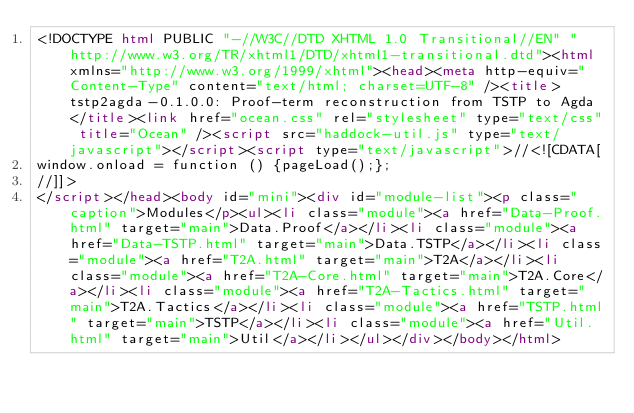<code> <loc_0><loc_0><loc_500><loc_500><_HTML_><!DOCTYPE html PUBLIC "-//W3C//DTD XHTML 1.0 Transitional//EN" "http://www.w3.org/TR/xhtml1/DTD/xhtml1-transitional.dtd"><html xmlns="http://www.w3.org/1999/xhtml"><head><meta http-equiv="Content-Type" content="text/html; charset=UTF-8" /><title>tstp2agda-0.1.0.0: Proof-term reconstruction from TSTP to Agda</title><link href="ocean.css" rel="stylesheet" type="text/css" title="Ocean" /><script src="haddock-util.js" type="text/javascript"></script><script type="text/javascript">//<![CDATA[
window.onload = function () {pageLoad();};
//]]>
</script></head><body id="mini"><div id="module-list"><p class="caption">Modules</p><ul><li class="module"><a href="Data-Proof.html" target="main">Data.Proof</a></li><li class="module"><a href="Data-TSTP.html" target="main">Data.TSTP</a></li><li class="module"><a href="T2A.html" target="main">T2A</a></li><li class="module"><a href="T2A-Core.html" target="main">T2A.Core</a></li><li class="module"><a href="T2A-Tactics.html" target="main">T2A.Tactics</a></li><li class="module"><a href="TSTP.html" target="main">TSTP</a></li><li class="module"><a href="Util.html" target="main">Util</a></li></ul></div></body></html></code> 